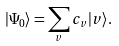<formula> <loc_0><loc_0><loc_500><loc_500>| \Psi _ { 0 } \rangle = \sum _ { v } c _ { v } | v \rangle .</formula> 